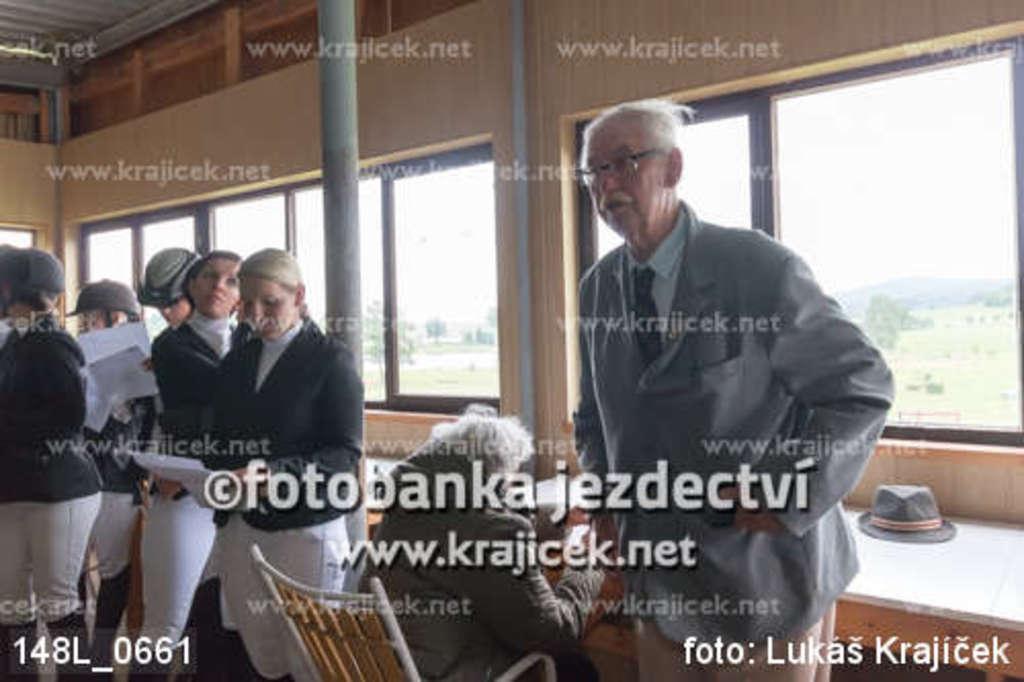Describe this image in one or two sentences. This is an inside view of a room. On the right side, I can see an old man wearing jacket, standing and looking towards the left side. Beside him there is a person is sitting on the chair. On the left side there are few people standing, holding papers in their hands. At the back of these people there is a pole and also I can see the windows to the wall. On this image I can see some text. 